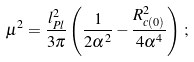<formula> <loc_0><loc_0><loc_500><loc_500>\mu ^ { 2 } = \frac { l _ { P l } ^ { 2 } } { 3 \pi } \left ( \frac { 1 } { 2 \alpha ^ { 2 } } - \frac { R _ { c ( 0 ) } ^ { 2 } } { 4 \alpha ^ { 4 } } \right ) \, ;</formula> 